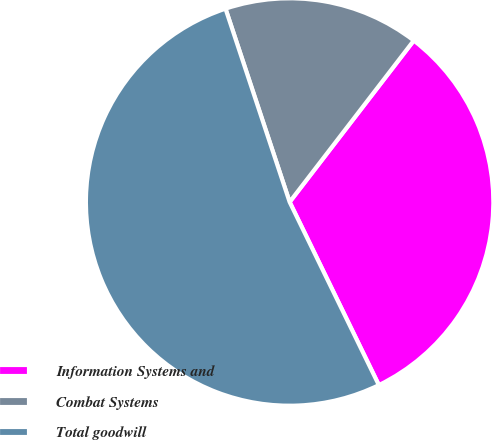<chart> <loc_0><loc_0><loc_500><loc_500><pie_chart><fcel>Information Systems and<fcel>Combat Systems<fcel>Total goodwill<nl><fcel>32.35%<fcel>15.53%<fcel>52.12%<nl></chart> 